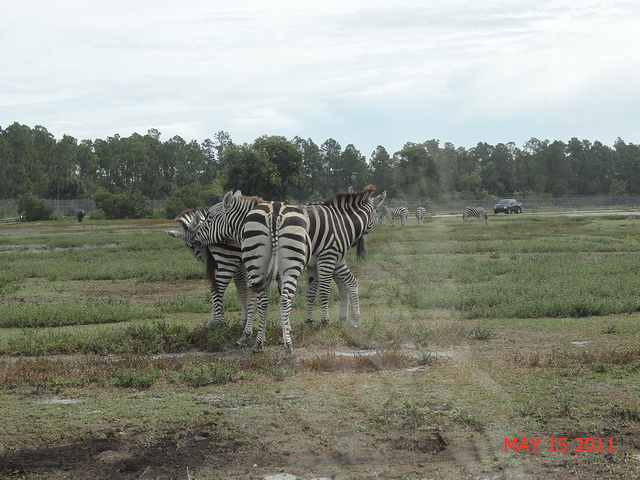How many zebras are in the picture? 3 